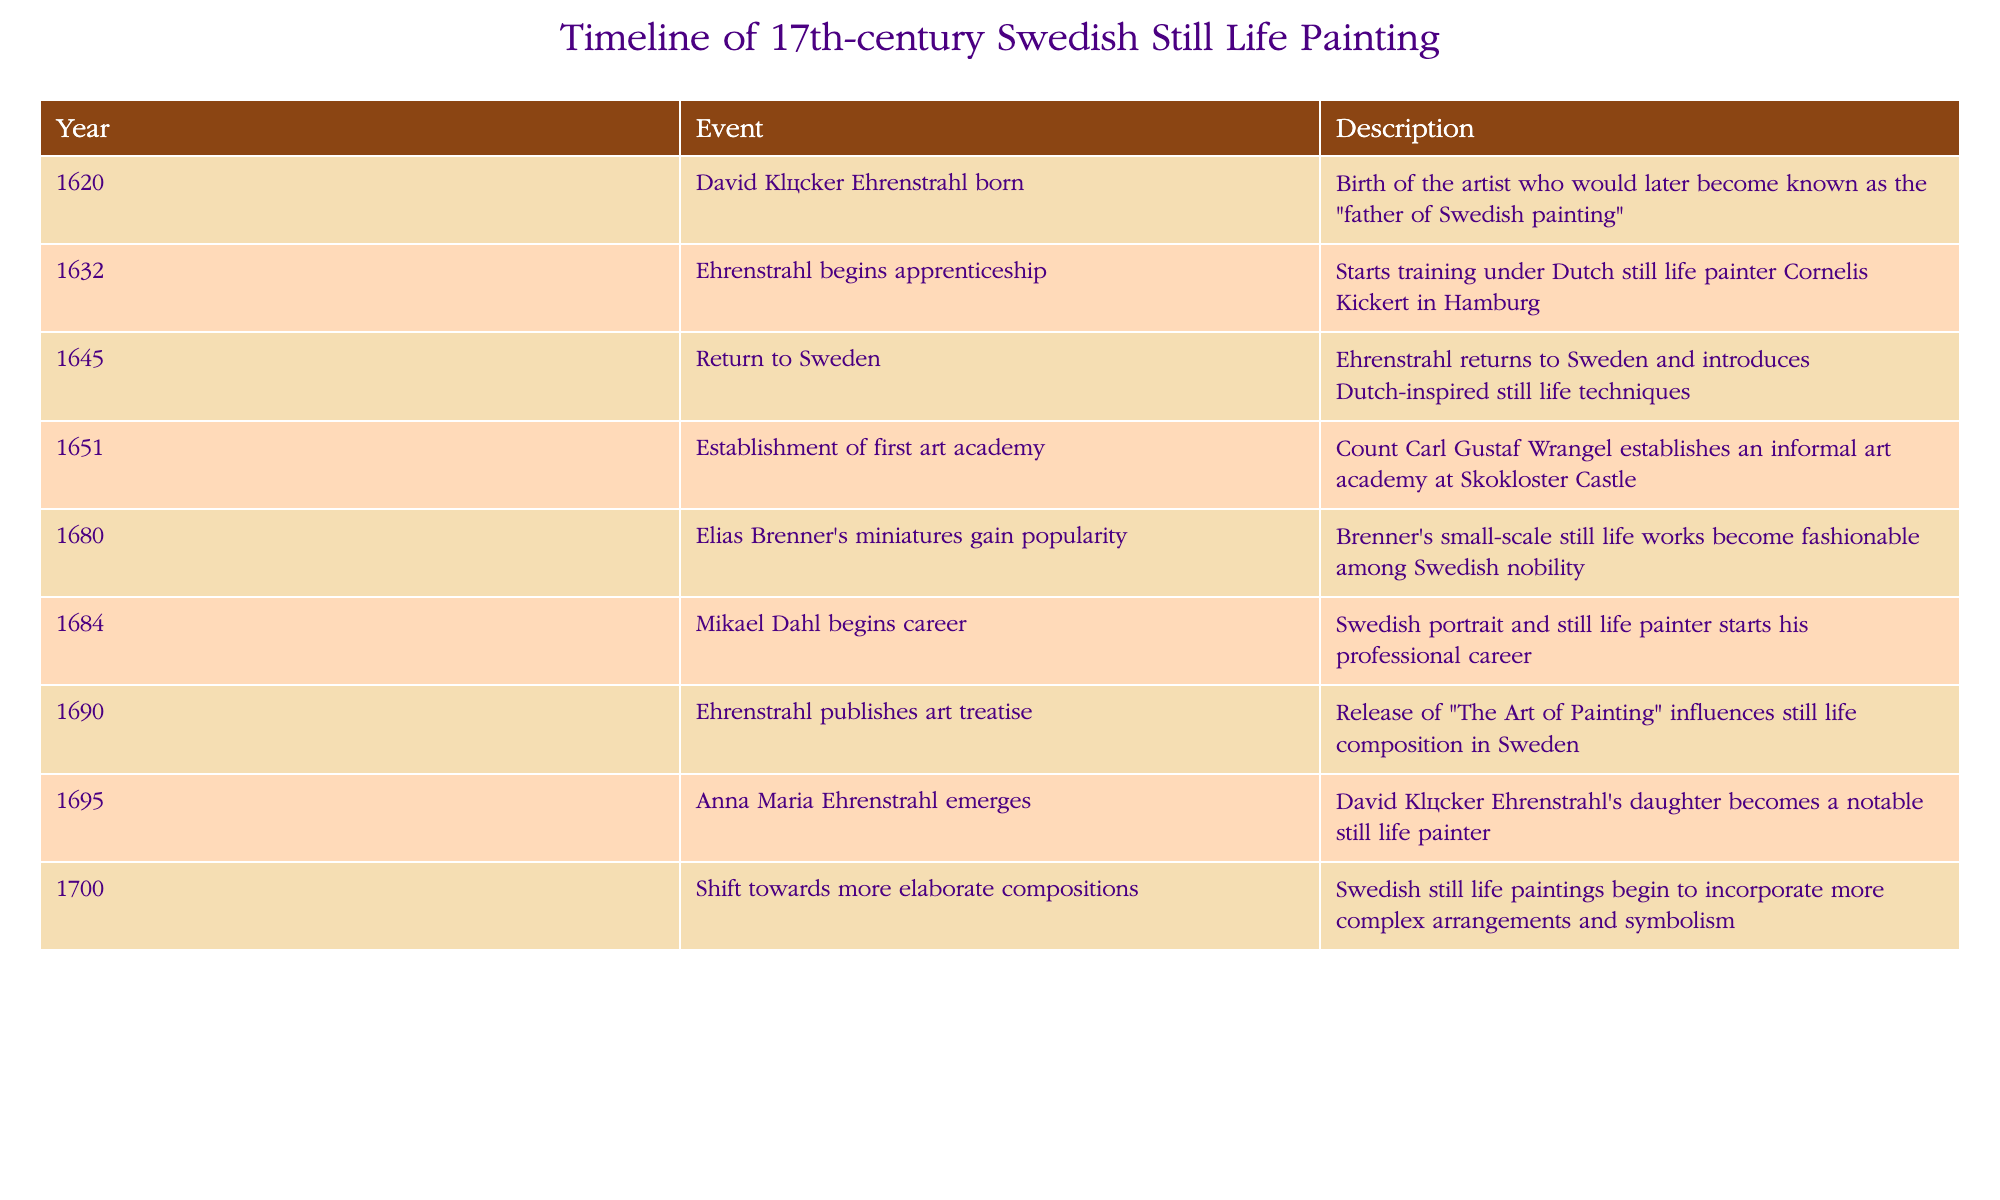What year was David Klöcker Ehrenstrahl born? The table states that David Klöcker Ehrenstrahl was born in the year 1620.
Answer: 1620 When did Ehrenstrahl begin his apprenticeship? Referring to the table, Ehrenstrahl began his apprenticeship in 1632.
Answer: 1632 How many notable events occurred after 1680? The table lists events from 1680 to 1700. There are 5 events listed in this range (from 1680 to 1700).
Answer: 5 Was Anna Maria Ehrenstrahl's emergence as a notable still life painter before 1700? According to the table, Anna Maria Ehrenstrahl emerged in 1695, which is indeed before the year 1700.
Answer: Yes What is the difference in years between the establishment of the first art academy and Ehrenstrahl's return to Sweden? The art academy was established in 1651, and Ehrenstrahl returned to Sweden in 1645. The difference is 1651 - 1645 = 6 years.
Answer: 6 years What influence did Ehrenstrahl's treatise have on still life composition based on the timeline? The timeline states that Ehrenstrahl published "The Art of Painting" in 1690, which influenced still life composition significantly in Sweden. Assessing its timing, it was after several key developments in still life painting, highlighting its importance in shaping future works.
Answer: It significantly influenced future compositions Which event marked the popularity of miniatures in still life works? The table indicates that the popularity of Elias Brenner's miniatures occurred in 1680, making it a notable event within Swedish still life trends.
Answer: 1680 Did Swedish still life painting shift towards more elaborate compositions after 1700? The table states that the shift towards more elaborate compositions began in 1700, indicating that it did not occur after, but rather at this specific time.
Answer: No 